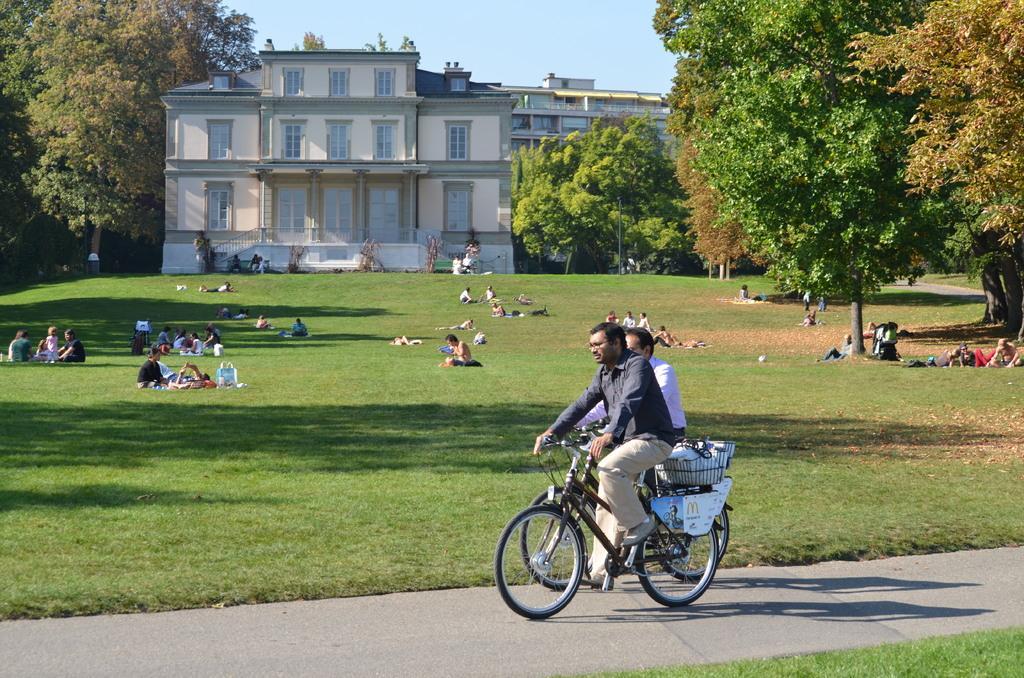Could you give a brief overview of what you see in this image? In this image In the middle there are two men riding bicycles. In the back ground there are many people sitting on the grass and some are sleeping and there is a building, trees and sky. 